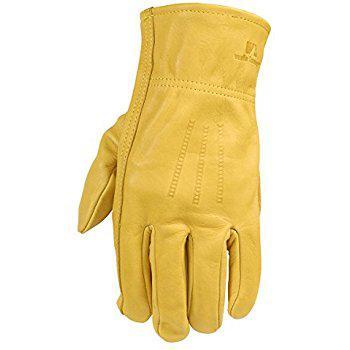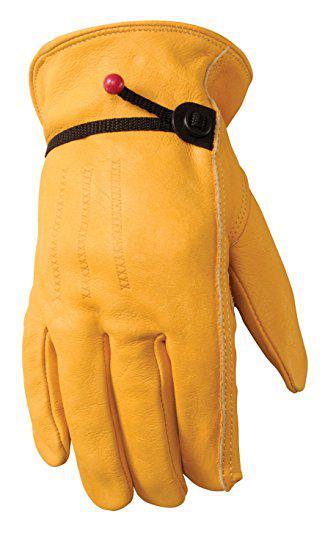The first image is the image on the left, the second image is the image on the right. For the images shown, is this caption "Each image shows a pair of work gloves and in one of the images the gloves are a single color." true? Answer yes or no. No. 